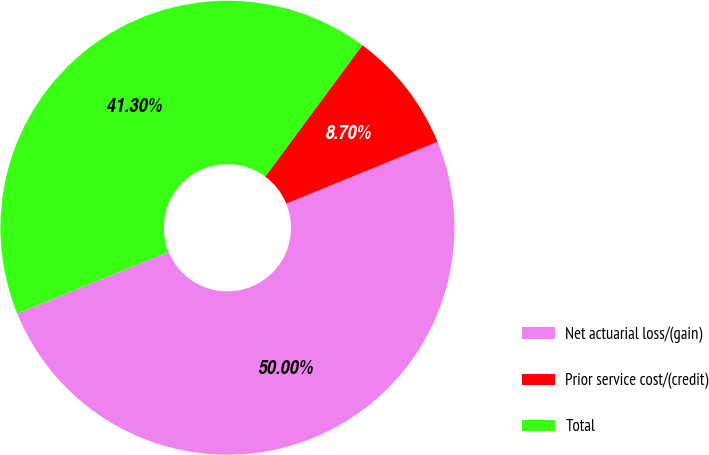<chart> <loc_0><loc_0><loc_500><loc_500><pie_chart><fcel>Net actuarial loss/(gain)<fcel>Prior service cost/(credit)<fcel>Total<nl><fcel>50.0%<fcel>8.7%<fcel>41.3%<nl></chart> 